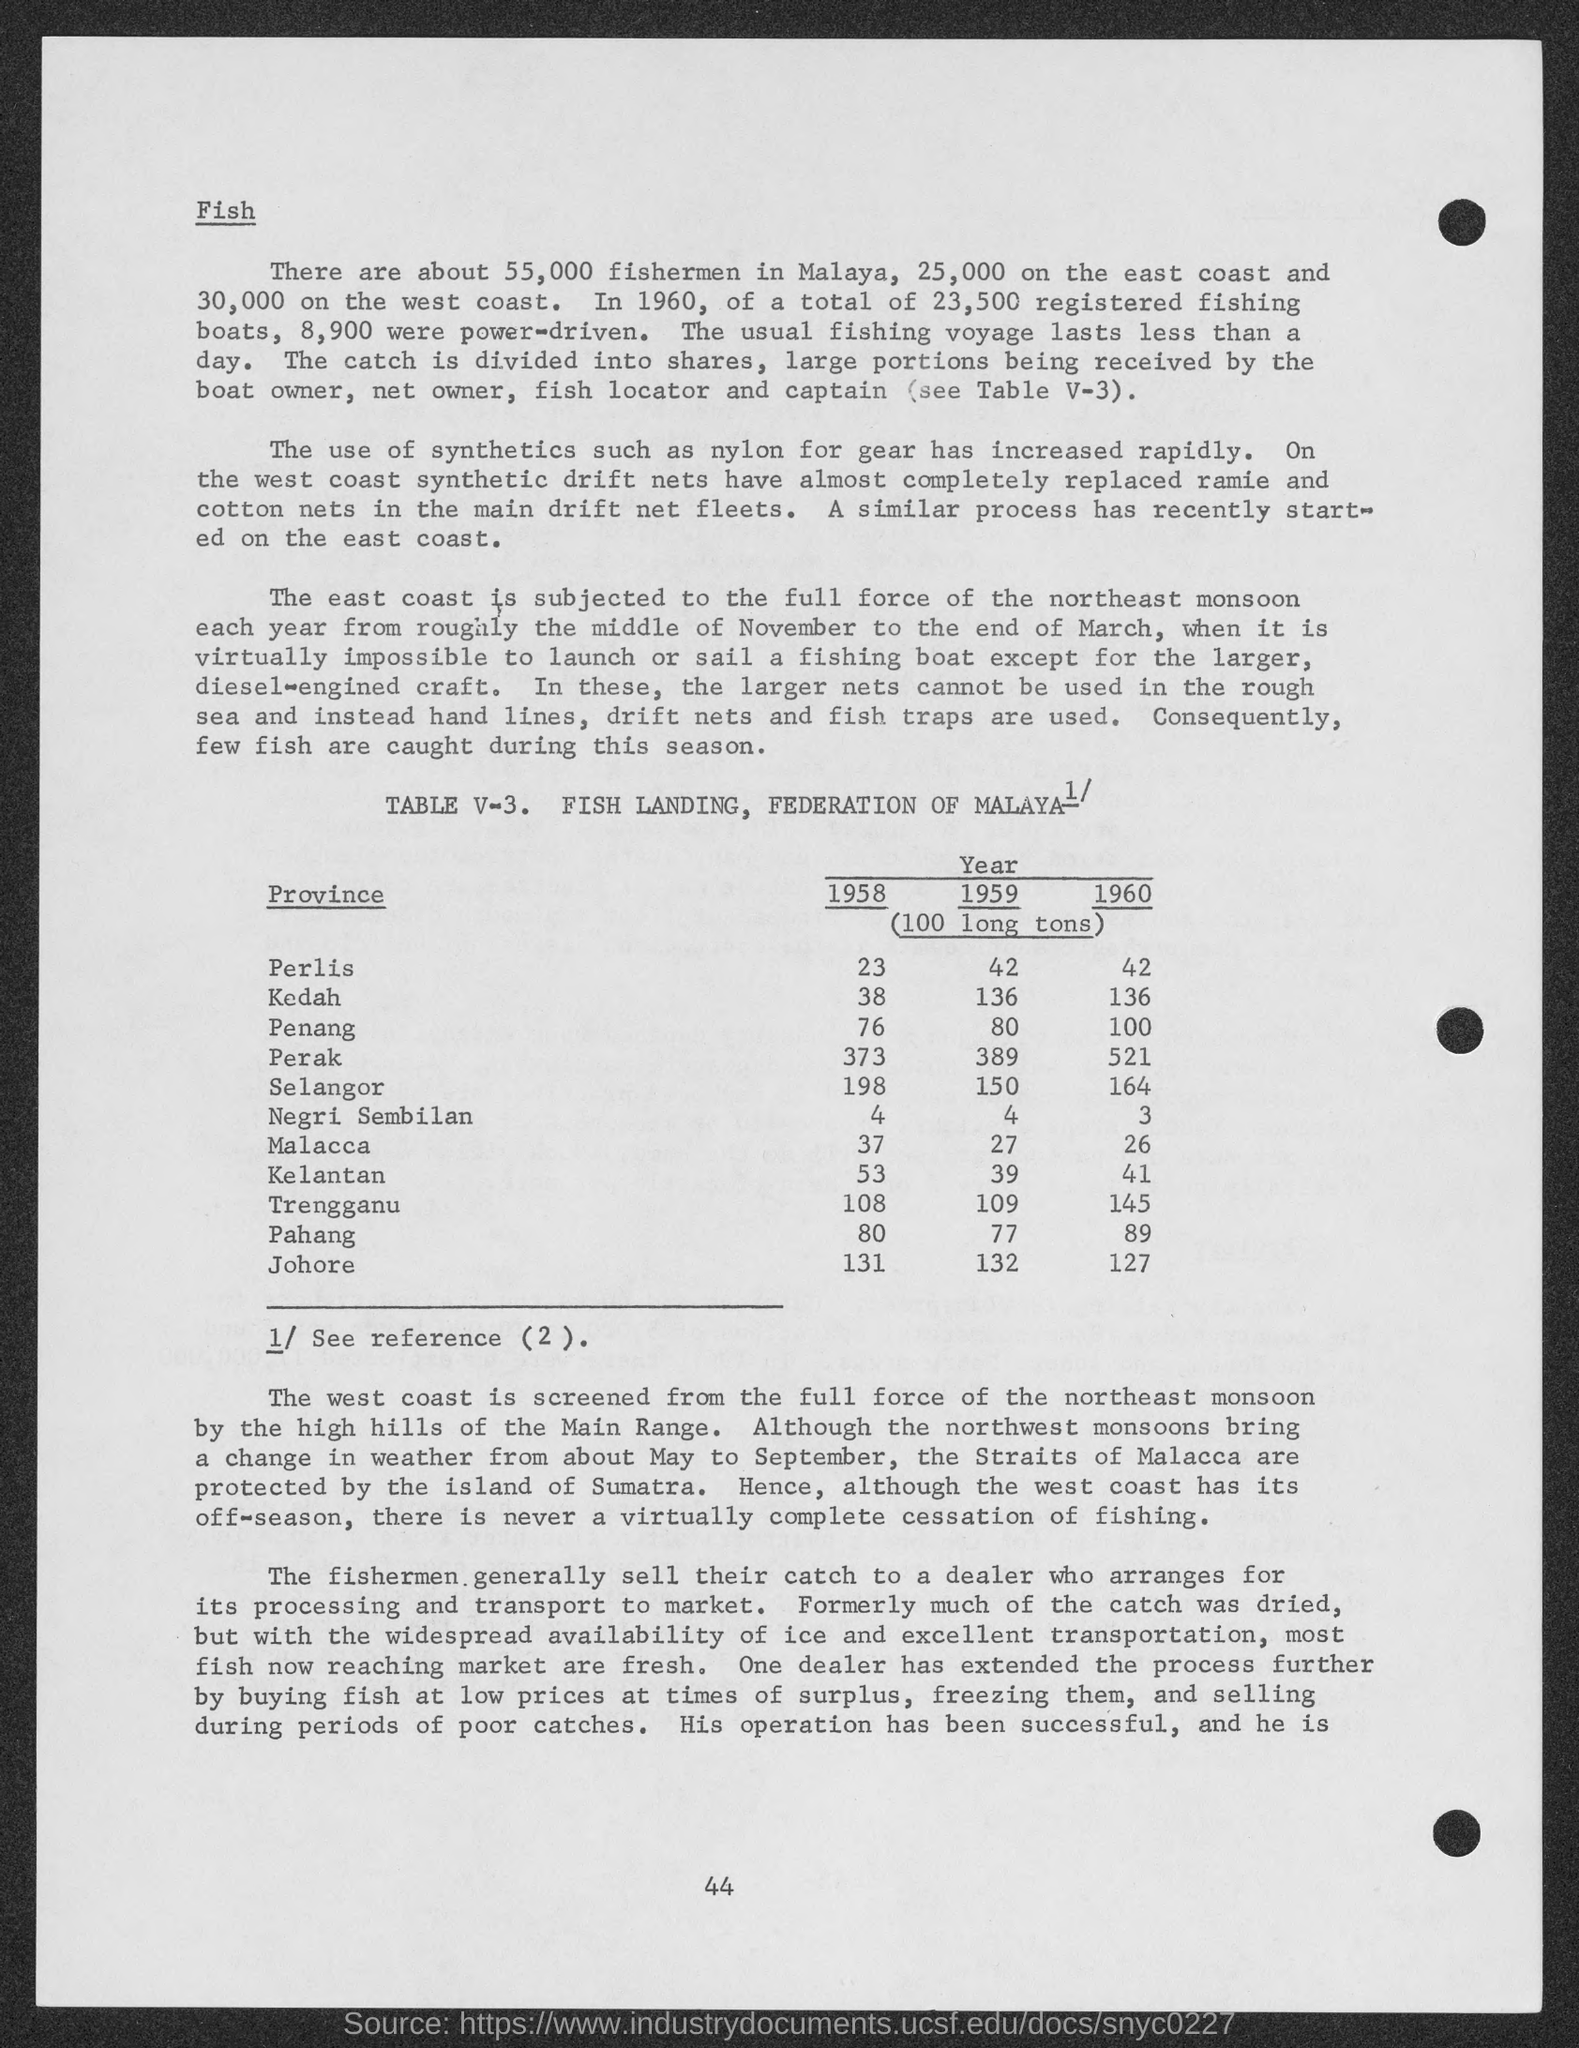Identify some key points in this picture. In 1958, the amount of 100 long tons in Kedah was equal to 38. In 1958, the amount of 100 long tons in Negri Sembilan was X. In 1958, the amount of 100 long tons in Malacca was equivalent to 37 units. In 1958, the amount of 100 long tons of perils was equivalent to 23. As of 1958, the amount of 100 long tons in Penang was 76. 